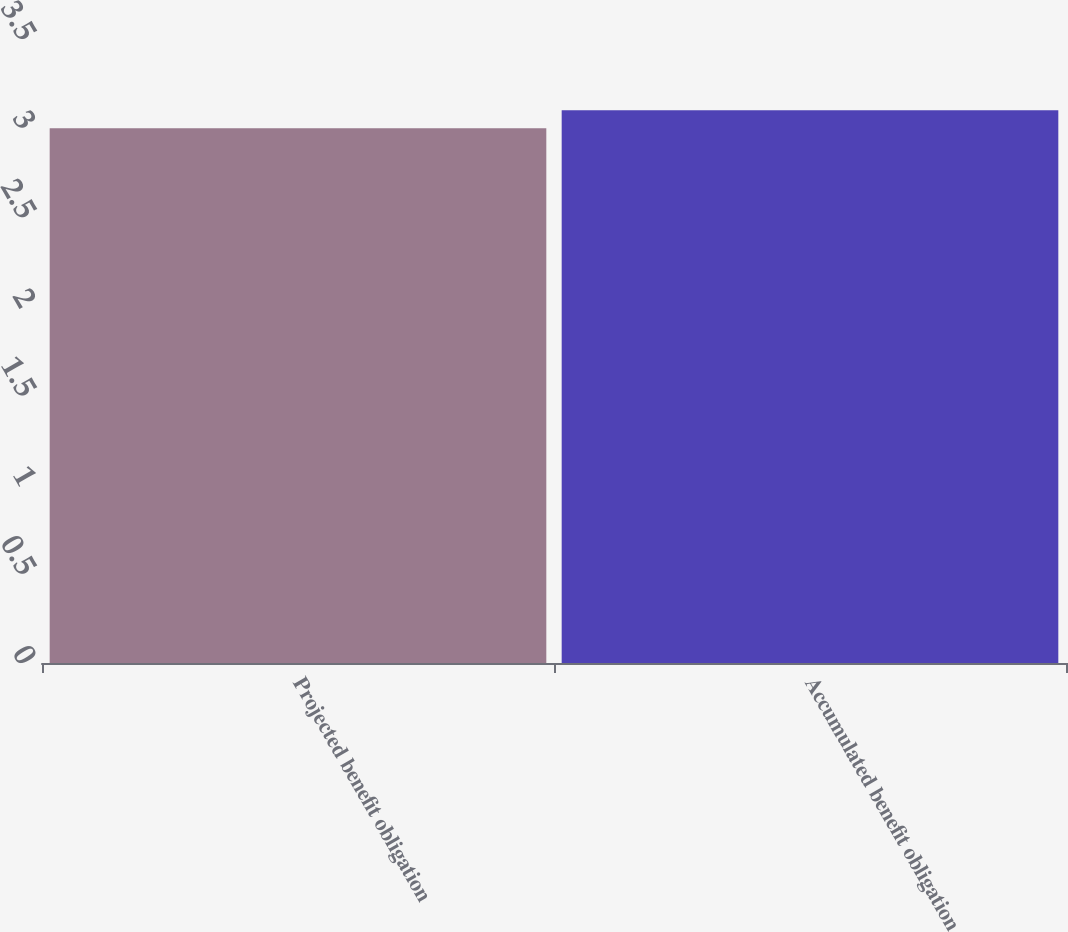Convert chart. <chart><loc_0><loc_0><loc_500><loc_500><bar_chart><fcel>Projected benefit obligation<fcel>Accumulated benefit obligation<nl><fcel>3<fcel>3.1<nl></chart> 